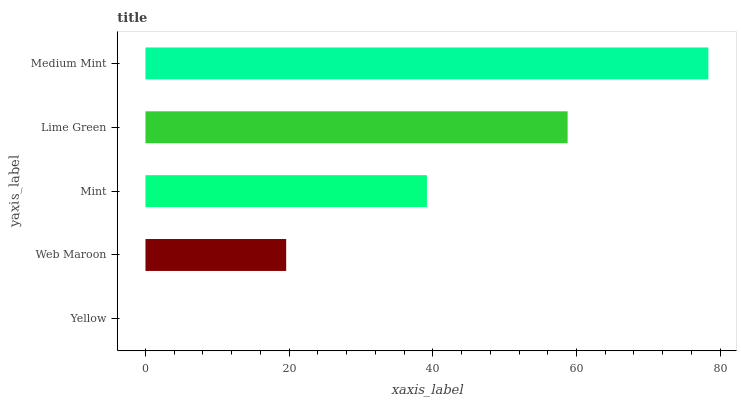Is Yellow the minimum?
Answer yes or no. Yes. Is Medium Mint the maximum?
Answer yes or no. Yes. Is Web Maroon the minimum?
Answer yes or no. No. Is Web Maroon the maximum?
Answer yes or no. No. Is Web Maroon greater than Yellow?
Answer yes or no. Yes. Is Yellow less than Web Maroon?
Answer yes or no. Yes. Is Yellow greater than Web Maroon?
Answer yes or no. No. Is Web Maroon less than Yellow?
Answer yes or no. No. Is Mint the high median?
Answer yes or no. Yes. Is Mint the low median?
Answer yes or no. Yes. Is Medium Mint the high median?
Answer yes or no. No. Is Yellow the low median?
Answer yes or no. No. 